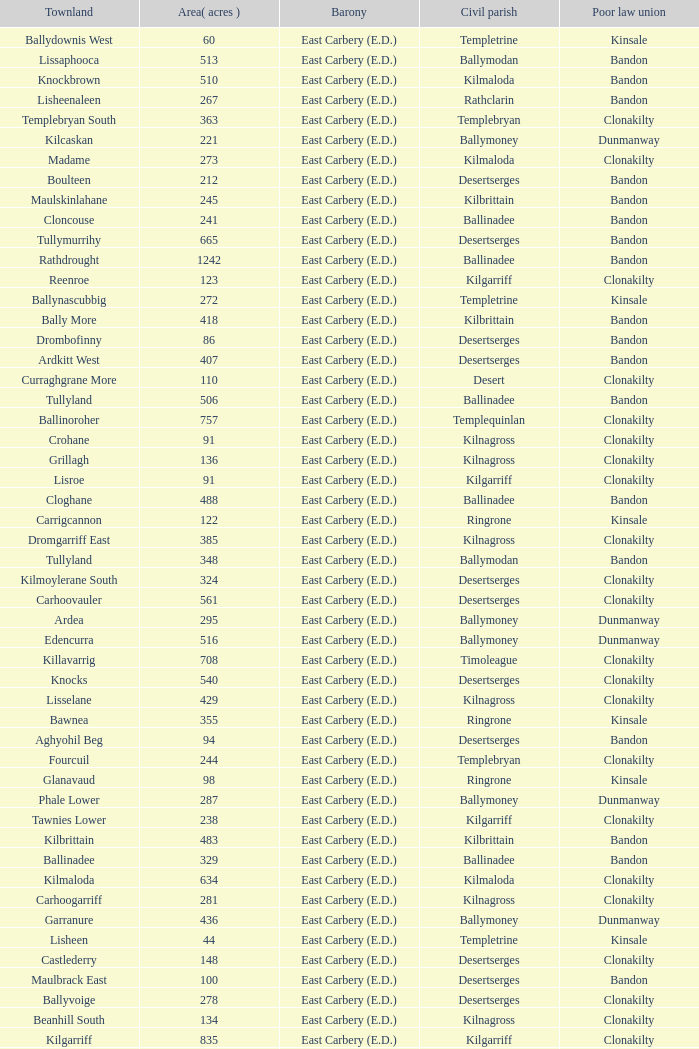What is the poor law union of the Ardacrow townland? Bandon. 